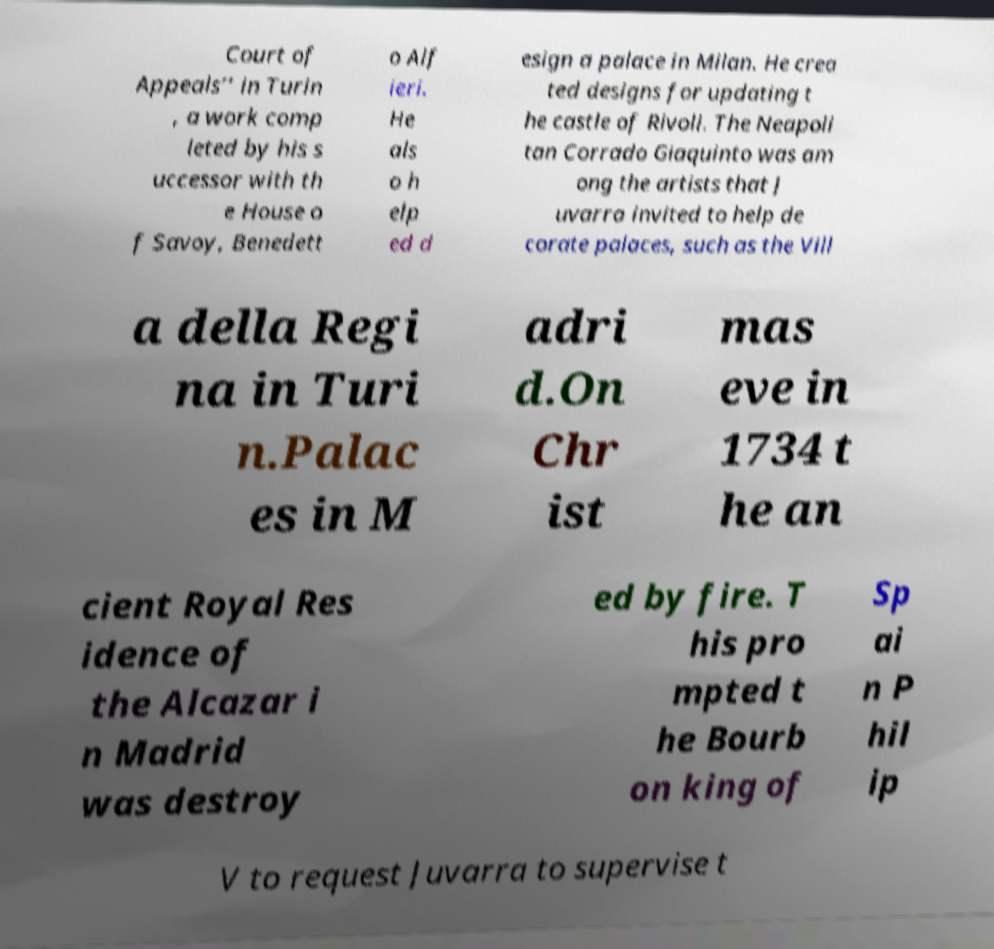There's text embedded in this image that I need extracted. Can you transcribe it verbatim? Court of Appeals’’ in Turin , a work comp leted by his s uccessor with th e House o f Savoy, Benedett o Alf ieri. He als o h elp ed d esign a palace in Milan. He crea ted designs for updating t he castle of Rivoli. The Neapoli tan Corrado Giaquinto was am ong the artists that J uvarra invited to help de corate palaces, such as the Vill a della Regi na in Turi n.Palac es in M adri d.On Chr ist mas eve in 1734 t he an cient Royal Res idence of the Alcazar i n Madrid was destroy ed by fire. T his pro mpted t he Bourb on king of Sp ai n P hil ip V to request Juvarra to supervise t 